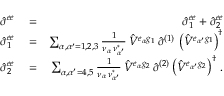Convert formula to latex. <formula><loc_0><loc_0><loc_500><loc_500>\begin{array} { r l r } { { \hat { \sigma } } ^ { e e } } & = } & { { \hat { \sigma } } _ { 1 } ^ { e e } + { \hat { \sigma } } _ { 2 } ^ { e e } } \\ { { \hat { \sigma } } _ { 1 } ^ { e e } } & = } & { \sum _ { { \alpha } , { \alpha ^ { \prime } } = 1 , 2 , 3 } \frac { 1 } { \nu _ { \alpha } \, \nu _ { \alpha ^ { \prime } } ^ { * } } \, { \hat { V } } ^ { e _ { \alpha } g _ { 1 } } \, { \hat { \sigma } } ^ { ( 1 ) } \, \left ( { \hat { V } } ^ { e _ { \alpha ^ { \prime } } g _ { 1 } } \right ) ^ { \dagger } } \\ { { \hat { \sigma } } _ { 2 } ^ { e e } } & = } & { \sum _ { { \alpha } , { \alpha ^ { \prime } } = 4 , 5 } \frac { 1 } { \nu _ { \alpha } \, \nu _ { \alpha ^ { \prime } } ^ { * } } \, { \hat { V } } ^ { e _ { \alpha } g _ { 2 } } \, { \hat { \sigma } } ^ { ( 2 ) } \left ( { \hat { V } } ^ { e _ { \alpha ^ { \prime } } g _ { 2 } } \right ) ^ { \dagger } \, . } \end{array}</formula> 